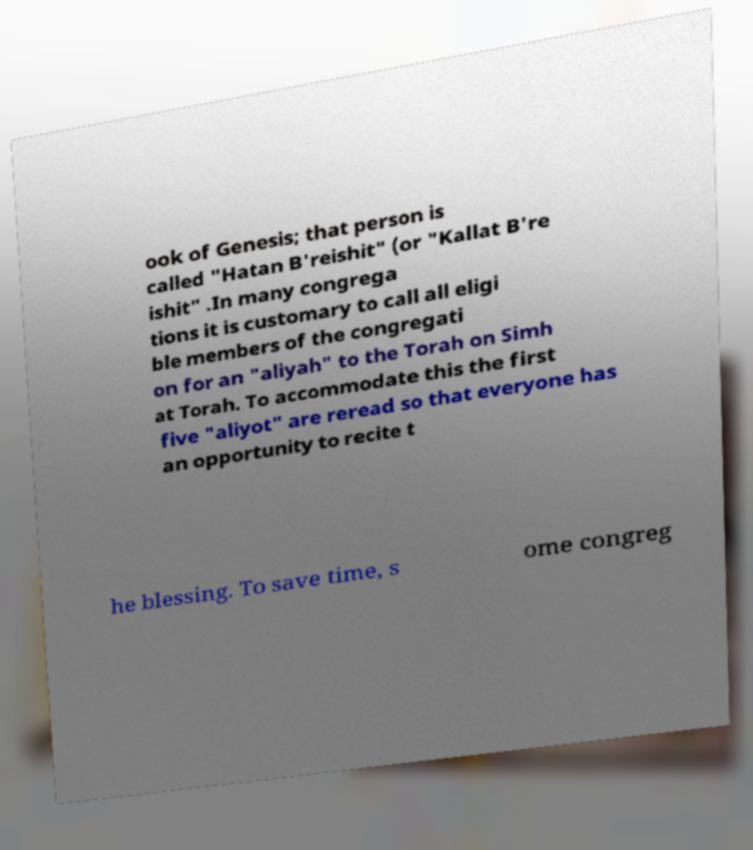I need the written content from this picture converted into text. Can you do that? ook of Genesis; that person is called "Hatan B'reishit" (or "Kallat B're ishit" .In many congrega tions it is customary to call all eligi ble members of the congregati on for an "aliyah" to the Torah on Simh at Torah. To accommodate this the first five "aliyot" are reread so that everyone has an opportunity to recite t he blessing. To save time, s ome congreg 